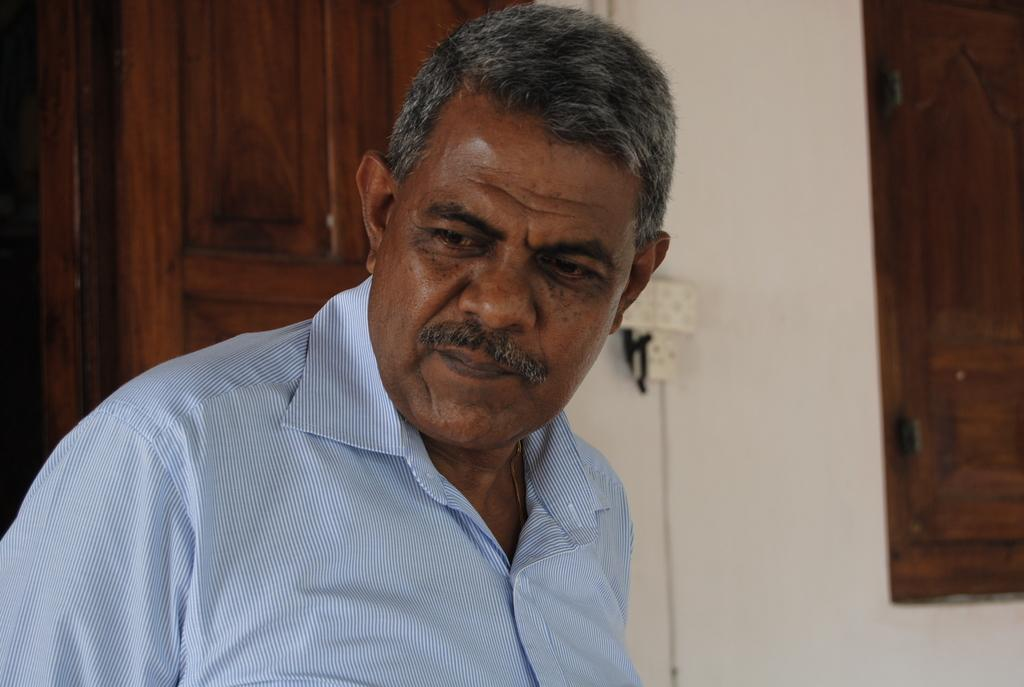Who is present in the image? There is a man in the image. What is the man wearing? The man is wearing a blue shirt. What can be seen through the windows in the image? The contents of the scene outside the windows are not visible, but the presence of windows indicates that there is a view of the outdoors. What color is the wall in the image? There is a white wall in the image. What is attached to the wall in the image? A switchboard is attached to the wall in the image. What type of stage is visible in the image? There is no stage present in the image. 